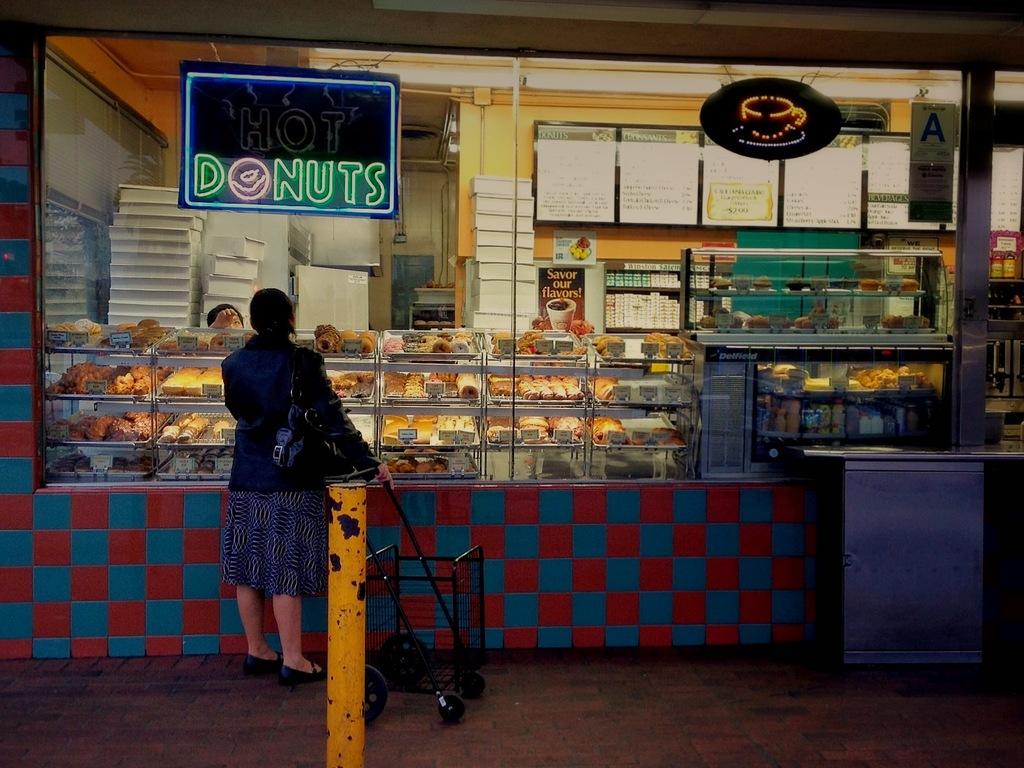What does this shop serve?
Ensure brevity in your answer.  Donuts. Is the store currently serving hot donuts?
Your response must be concise. Yes. 